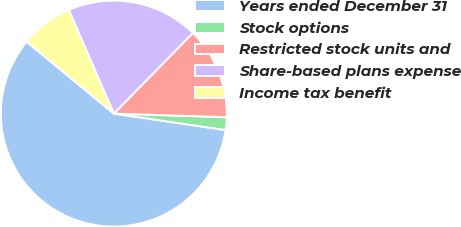<chart> <loc_0><loc_0><loc_500><loc_500><pie_chart><fcel>Years ended December 31<fcel>Stock options<fcel>Restricted stock units and<fcel>Share-based plans expense<fcel>Income tax benefit<nl><fcel>58.66%<fcel>1.81%<fcel>13.18%<fcel>18.86%<fcel>7.49%<nl></chart> 